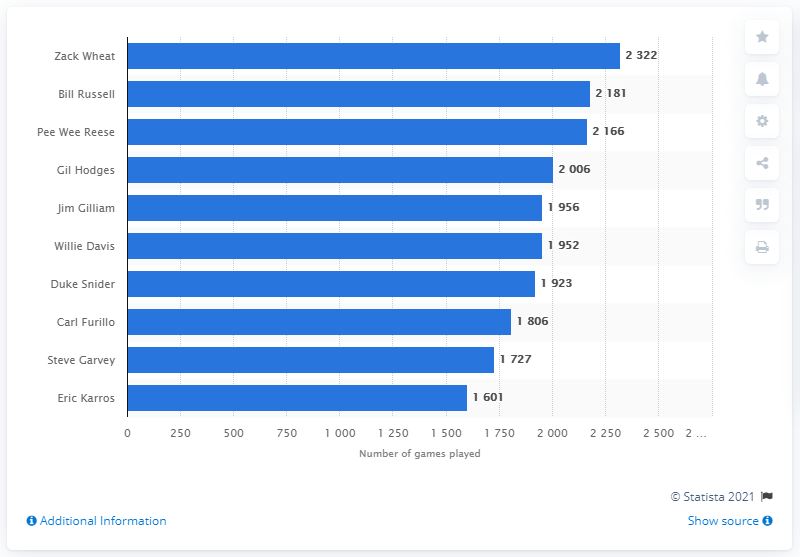Identify some key points in this picture. The individual who has played the most games in the history of the Los Angeles Dodgers franchise is Zack Wheat, who demonstrated exceptional skill and commitment during his tenure with the team. 